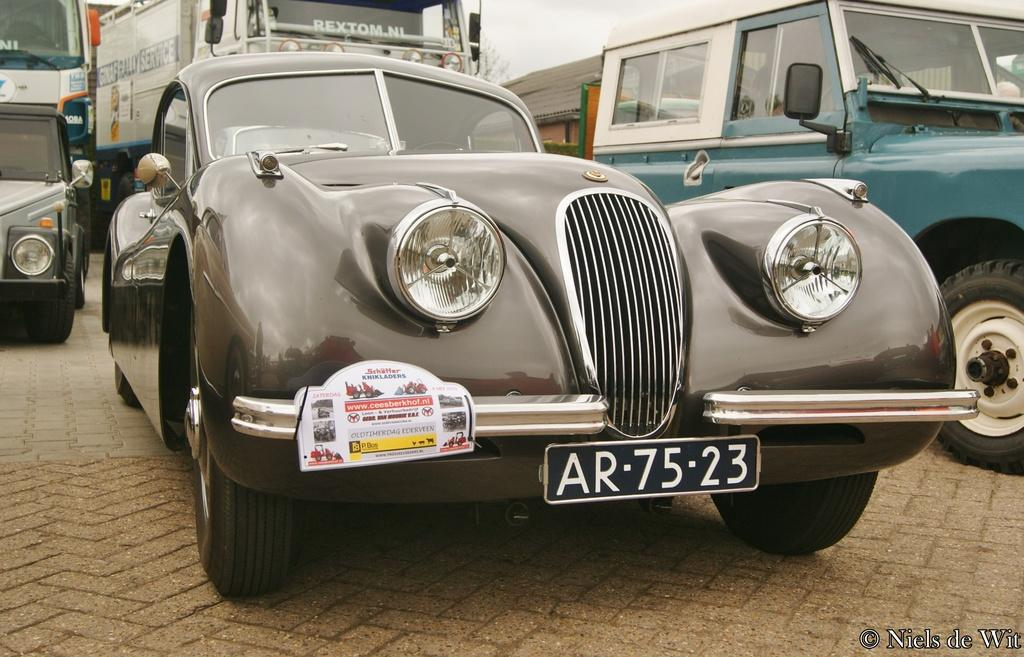What type of objects are present in the image? There are vehicles in the image. What specific features do the vehicles have? The vehicles have wheels, number plates, and information cards. Where can the watermark be found in the image? The watermark is at the bottom of the image. Can you tell me how many pizzas are being delivered by the vehicles in the image? There is no mention of pizzas or pizza delivery in the image; it only features vehicles with specific features. Are there any planes visible in the image? No, there are no planes present in the image; it only contains vehicles. 